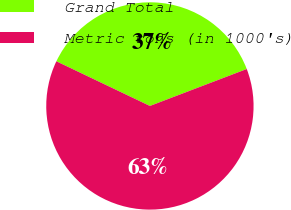<chart> <loc_0><loc_0><loc_500><loc_500><pie_chart><fcel>Grand Total<fcel>Metric tons (in 1000's)<nl><fcel>37.11%<fcel>62.89%<nl></chart> 